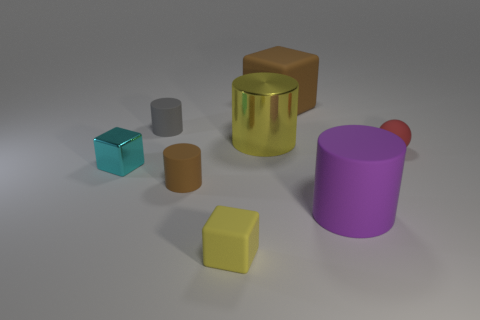Do the large shiny object and the tiny rubber block have the same color?
Your answer should be compact. Yes. What number of cylinders are both behind the cyan object and to the right of the yellow matte block?
Give a very brief answer. 1. Do the brown matte object that is on the left side of the large cube and the gray object have the same shape?
Your response must be concise. Yes. There is a sphere that is the same size as the yellow cube; what is it made of?
Offer a terse response. Rubber. Is the number of big blocks that are behind the yellow metal object the same as the number of red matte balls in front of the large brown block?
Ensure brevity in your answer.  Yes. There is a small rubber object that is to the right of the yellow thing in front of the purple thing; what number of yellow cylinders are to the left of it?
Offer a very short reply. 1. Do the large shiny thing and the rubber cube on the left side of the yellow cylinder have the same color?
Your response must be concise. Yes. There is a red ball that is the same material as the tiny gray thing; what size is it?
Keep it short and to the point. Small. Are there more cubes that are in front of the tiny cyan thing than green shiny cubes?
Provide a succinct answer. Yes. What is the material of the yellow thing behind the tiny matte cube in front of the rubber cylinder in front of the small brown thing?
Your answer should be very brief. Metal. 